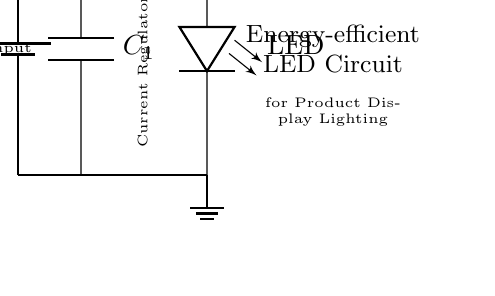What is the power source for this circuit? The circuit shows a battery labeled as V_in, indicating the power source is a battery.
Answer: battery What is the component used to limit the current? A resistor, labeled as R_1, is present in the circuit and serves the function of limiting the current.
Answer: resistor What is the purpose of the capacitor in the circuit? The capacitor labeled C_1 is used for smoothing, which helps to stabilize voltage and reduce fluctuations.
Answer: smoothing How many LEDs are shown in the circuit? The diagram depicts a single LED as indicated in the circuit with the label LED.
Answer: one What type of LED does this circuit utilize? The circuit indicates a bright, low-power LED suitable for energy-efficient applications.
Answer: bright, low-power LED What does the current regulator do in this circuit? The current regulator in this circuit controls the amount of current flowing through the LED to ensure it operates efficiently without burning out.
Answer: controls current What is the significance of the label "Low Voltage Input"? The label indicates that the circuit is designed to operate efficiently with low voltage, making it suitable for energy-efficient appliances.
Answer: low voltage 